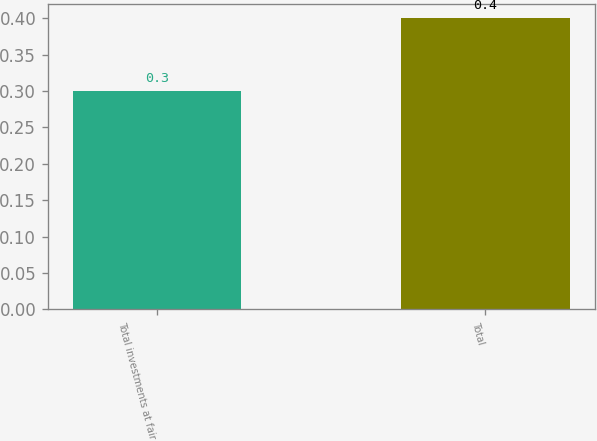<chart> <loc_0><loc_0><loc_500><loc_500><bar_chart><fcel>Total investments at fair<fcel>Total<nl><fcel>0.3<fcel>0.4<nl></chart> 